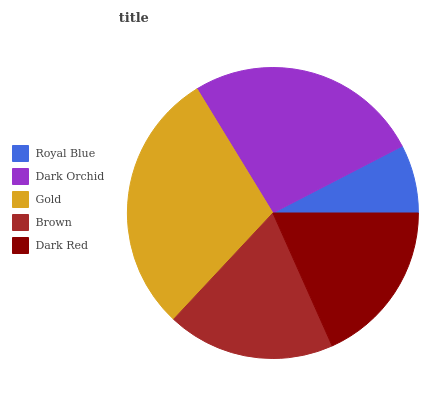Is Royal Blue the minimum?
Answer yes or no. Yes. Is Gold the maximum?
Answer yes or no. Yes. Is Dark Orchid the minimum?
Answer yes or no. No. Is Dark Orchid the maximum?
Answer yes or no. No. Is Dark Orchid greater than Royal Blue?
Answer yes or no. Yes. Is Royal Blue less than Dark Orchid?
Answer yes or no. Yes. Is Royal Blue greater than Dark Orchid?
Answer yes or no. No. Is Dark Orchid less than Royal Blue?
Answer yes or no. No. Is Brown the high median?
Answer yes or no. Yes. Is Brown the low median?
Answer yes or no. Yes. Is Gold the high median?
Answer yes or no. No. Is Gold the low median?
Answer yes or no. No. 